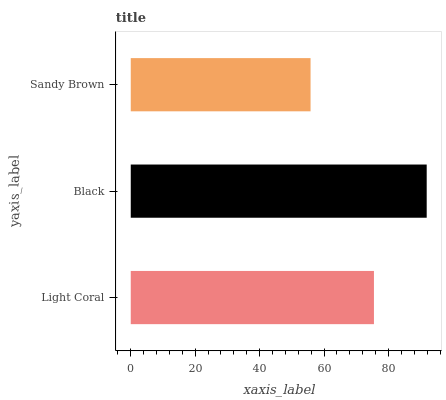Is Sandy Brown the minimum?
Answer yes or no. Yes. Is Black the maximum?
Answer yes or no. Yes. Is Black the minimum?
Answer yes or no. No. Is Sandy Brown the maximum?
Answer yes or no. No. Is Black greater than Sandy Brown?
Answer yes or no. Yes. Is Sandy Brown less than Black?
Answer yes or no. Yes. Is Sandy Brown greater than Black?
Answer yes or no. No. Is Black less than Sandy Brown?
Answer yes or no. No. Is Light Coral the high median?
Answer yes or no. Yes. Is Light Coral the low median?
Answer yes or no. Yes. Is Sandy Brown the high median?
Answer yes or no. No. Is Black the low median?
Answer yes or no. No. 